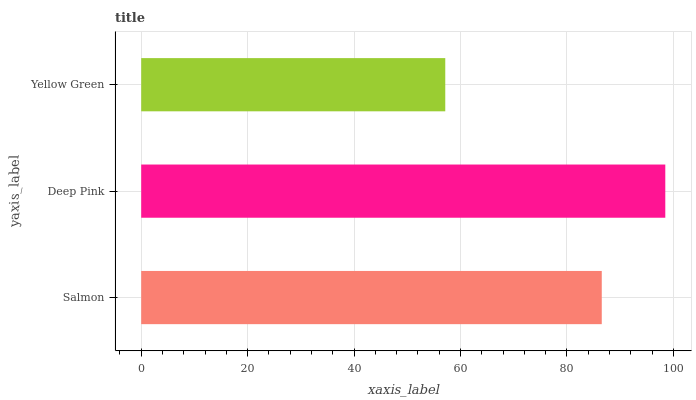Is Yellow Green the minimum?
Answer yes or no. Yes. Is Deep Pink the maximum?
Answer yes or no. Yes. Is Deep Pink the minimum?
Answer yes or no. No. Is Yellow Green the maximum?
Answer yes or no. No. Is Deep Pink greater than Yellow Green?
Answer yes or no. Yes. Is Yellow Green less than Deep Pink?
Answer yes or no. Yes. Is Yellow Green greater than Deep Pink?
Answer yes or no. No. Is Deep Pink less than Yellow Green?
Answer yes or no. No. Is Salmon the high median?
Answer yes or no. Yes. Is Salmon the low median?
Answer yes or no. Yes. Is Yellow Green the high median?
Answer yes or no. No. Is Deep Pink the low median?
Answer yes or no. No. 